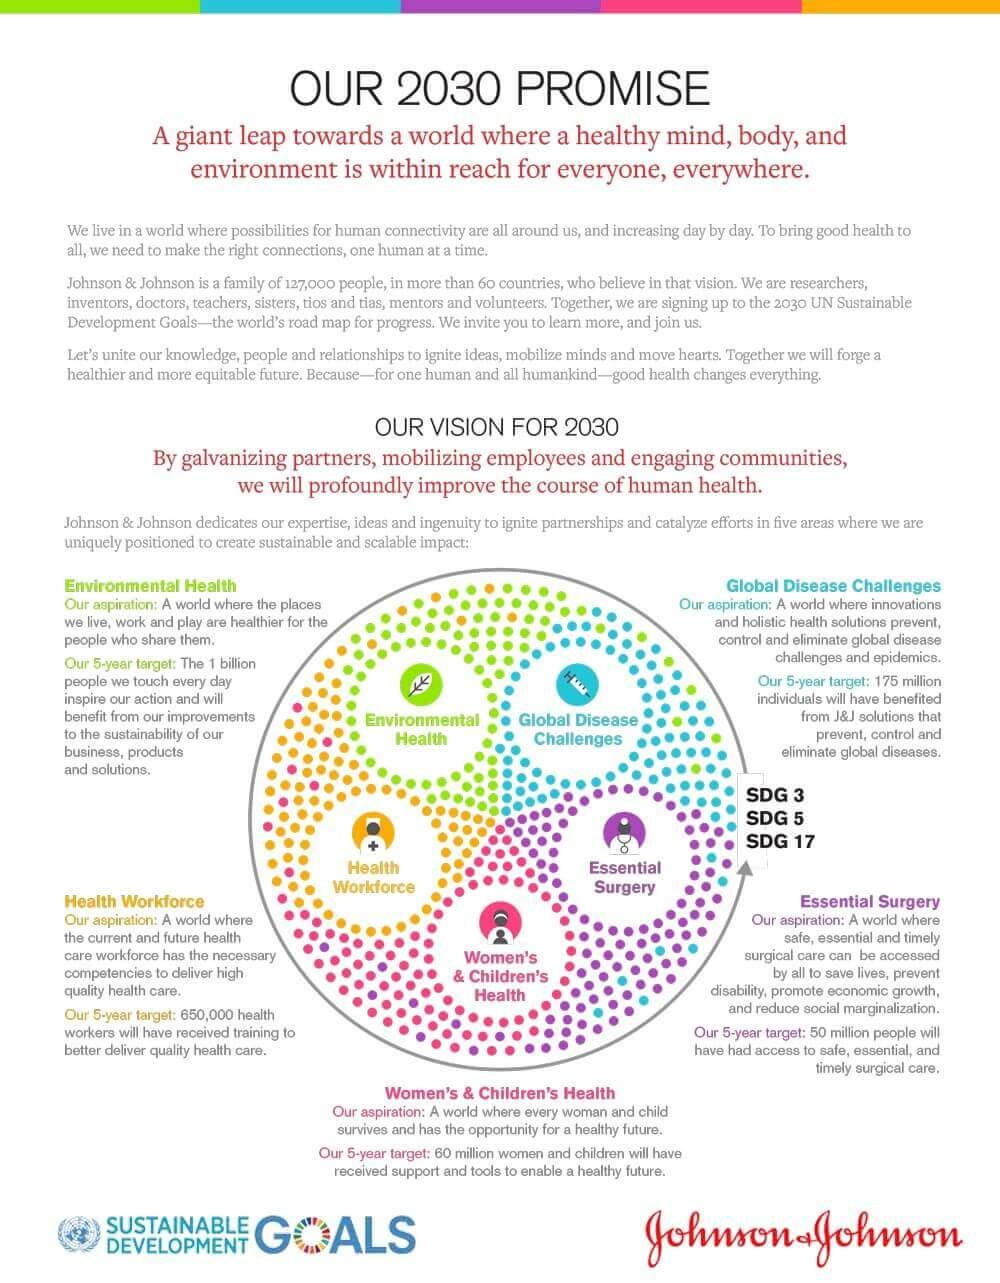Outline some significant characteristics in this image. The solution to global disease challenges is expected to benefit 175 million people in the next five years. The color green represents environmental health in the infographic. The color blue represents global disease challenges in the infographic. I declare that the color representing "women's & Children's Health" in the infographic should be red. Our organization aims to provide support to 60 million women and children over the next five years, in order to enable healthy and prosperous futures for all. 